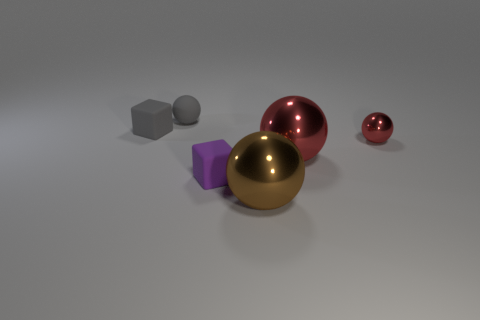Subtract all gray rubber balls. How many balls are left? 3 Subtract all brown spheres. How many spheres are left? 3 Subtract 1 spheres. How many spheres are left? 3 Add 2 metal spheres. How many objects exist? 8 Subtract all blue spheres. Subtract all cyan cylinders. How many spheres are left? 4 Subtract all cubes. How many objects are left? 4 Subtract all small green metal things. Subtract all large red metallic balls. How many objects are left? 5 Add 1 small gray things. How many small gray things are left? 3 Add 2 red things. How many red things exist? 4 Subtract 0 cyan spheres. How many objects are left? 6 